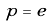Convert formula to latex. <formula><loc_0><loc_0><loc_500><loc_500>p = e</formula> 